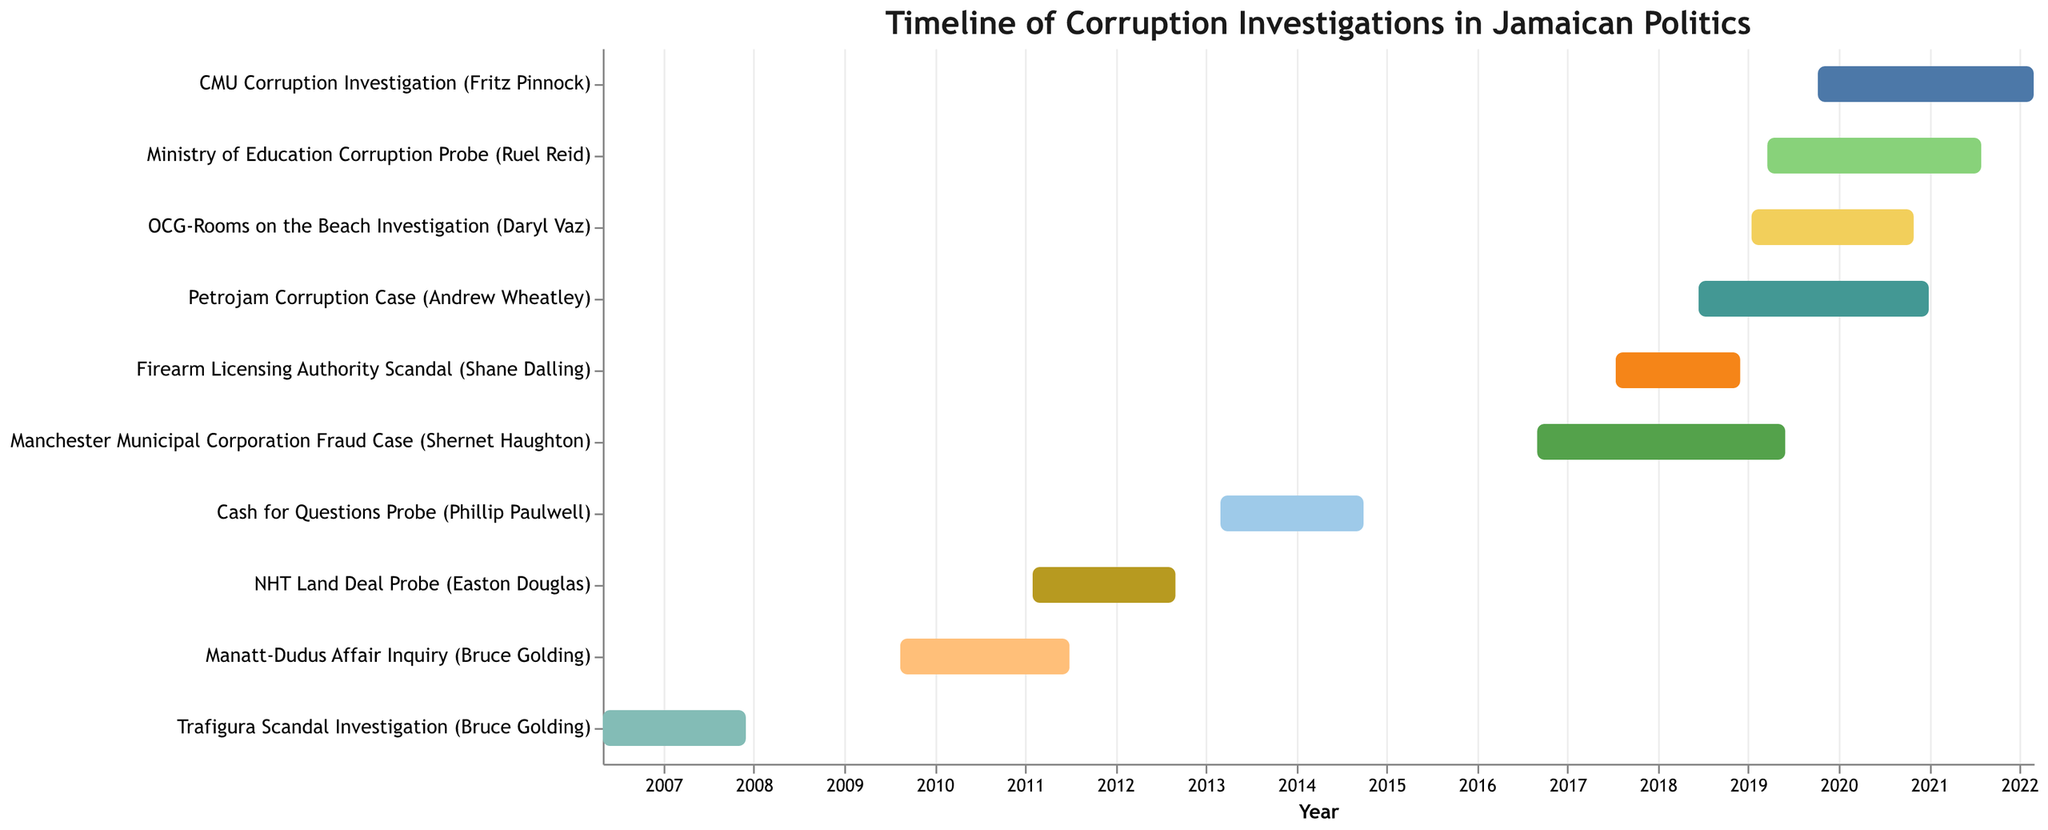What is the title of the figure? The title is typically found at the top center of the Gantt Chart and provides an overview of the content.
Answer: Timeline of Corruption Investigations in Jamaican Politics When did the Ministry of Education Corruption Probe start and end? Refer to the Gantt Chart bars to determine the starting and ending points of each investigation. Locate the bar for the Ministry of Education Corruption Probe and check the dates.
Answer: Start: March 20, 2019; End: July 31, 2021 Which corruption investigation had the shortest duration? Identify the timelines for each investigation on the Gantt Chart by noting the length of each bar. Compare the durations to find the shortest one.
Answer: Firearm Licensing Authority Scandal (Shane Dalling) How many corruption investigations spanned across the year 2019? Look for bars that cover any part of the year 2019 by checking their start and end dates. Count these bars.
Answer: Five Which investigation involving Bruce Golding lasted longer: Trafigura Scandal or Manatt-Dudus Affair? Compare the lengths of the bars for the Trafigura Scandal Investigation and the Manatt-Dudus Affair Inquiry by checking their start and end dates.
Answer: Manatt-Dudus Affair Inquiry What is the time difference between the start of the Trafigura Scandal Investigation and the end of the Manatt-Dudus Affair Inquiry? Note the start date of the Trafigura Scandal Investigation and the end date of the Manatt-Dudus Affair Inquiry. Calculate the time span between these two dates.
Answer: Approximately 5 years and 1 month How many investigations started after 2015? Find and count the bars that have a start date later than the year 2015 in the Gantt Chart.
Answer: Six Compare the duration of the CMU Corruption Investigation and the Petrojam Corruption Case. Which one lasted longer? Determine the duration of each investigation by calculating the difference between the start and end dates. Compare these values.
Answer: CMU Corruption Investigation Which investigations overlap with the Ministry of Education Corruption Probe? Identify the timeline of the Ministry of Education Corruption Probe and check for any bars that intersect with this period.
Answer: Petrojam Corruption Case, CMU Corruption Investigation, OCG-Rooms on the Beach Investigation Identify the investigation with the longest duration and provide its total duration in months. Measure the length of all the bars by calculating the time span (in months) from start to end dates for each. Find the longest.
Answer: CMU Corruption Investigation, 28 months 